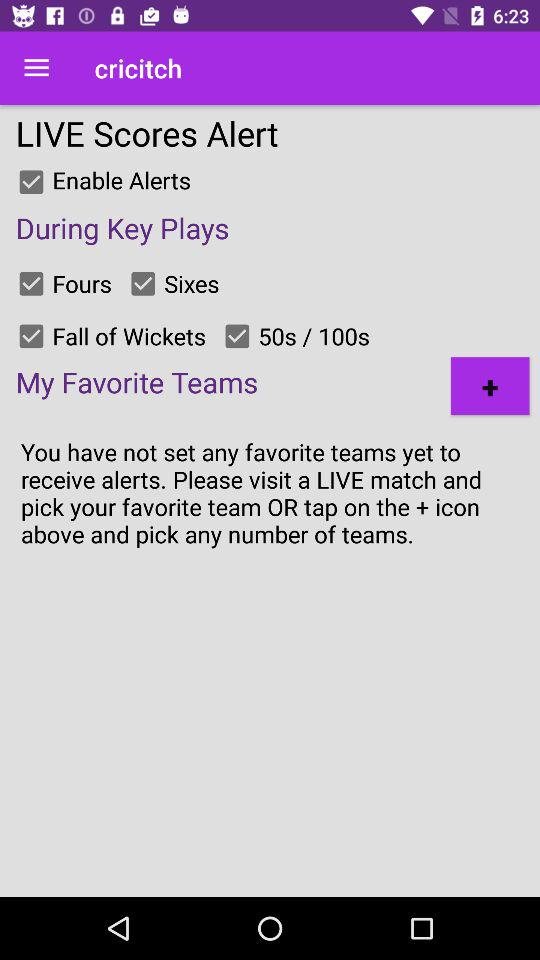What is the status of "Enable Alerts"? The status is "on". 